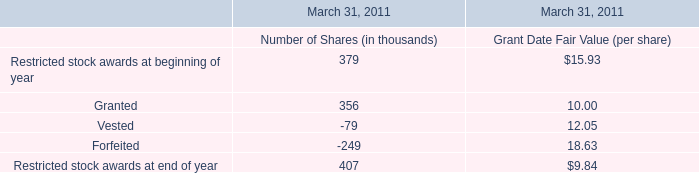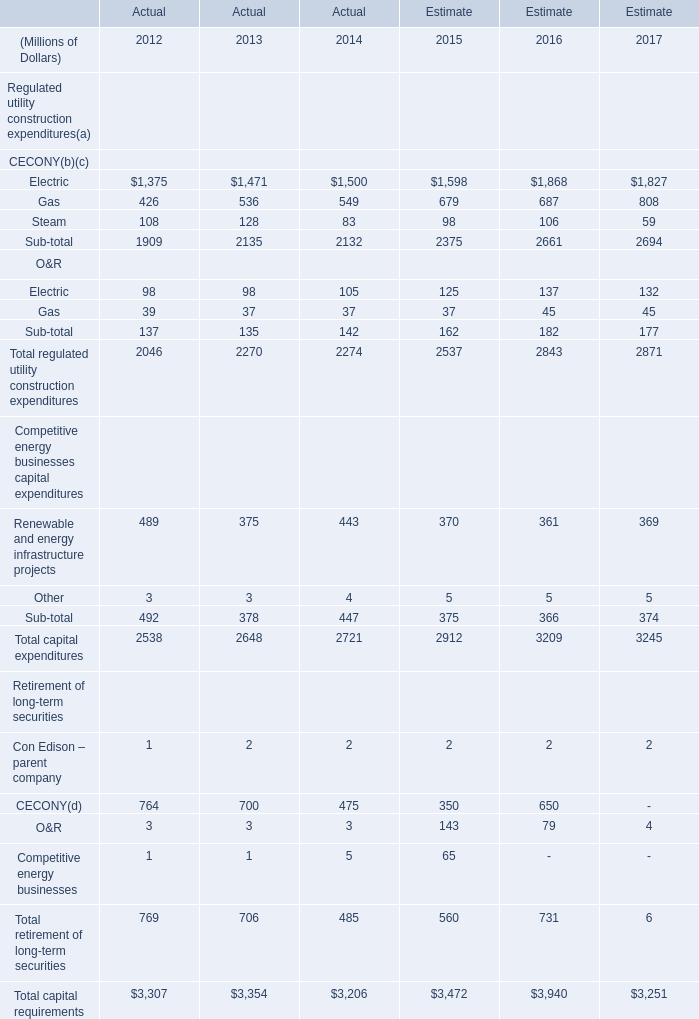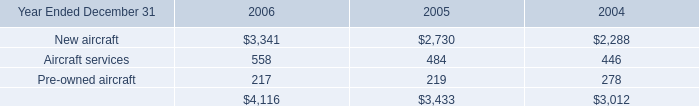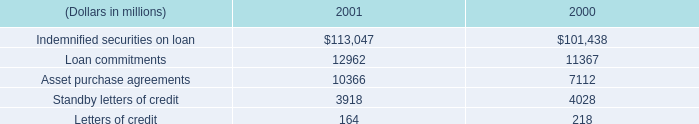How many years does Gas stay higher than Steam? 
Answer: 5. 